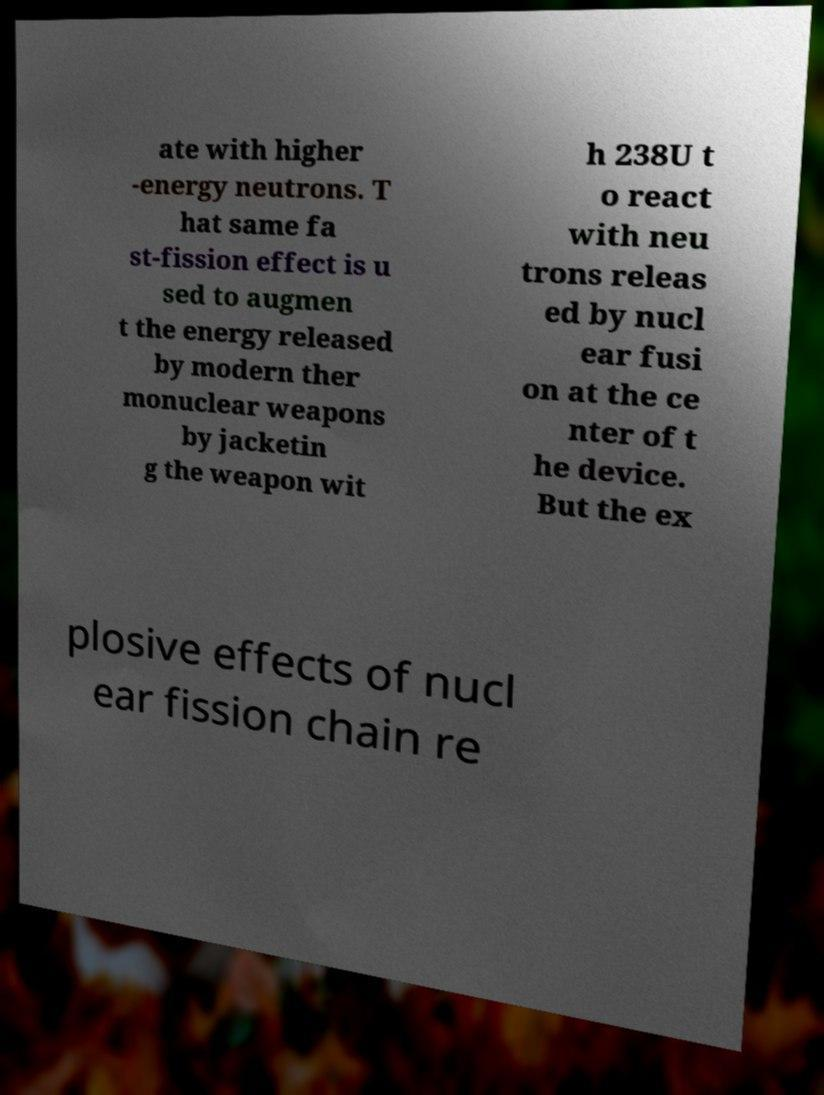Can you accurately transcribe the text from the provided image for me? ate with higher -energy neutrons. T hat same fa st-fission effect is u sed to augmen t the energy released by modern ther monuclear weapons by jacketin g the weapon wit h 238U t o react with neu trons releas ed by nucl ear fusi on at the ce nter of t he device. But the ex plosive effects of nucl ear fission chain re 